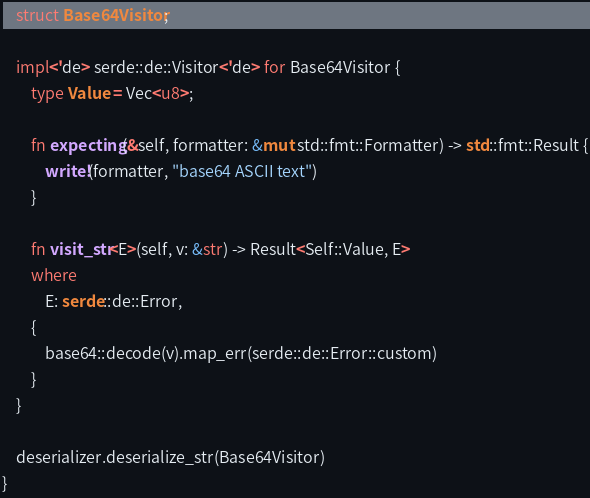Convert code to text. <code><loc_0><loc_0><loc_500><loc_500><_Rust_>    struct Base64Visitor;

    impl<'de> serde::de::Visitor<'de> for Base64Visitor {
        type Value = Vec<u8>;

        fn expecting(&self, formatter: &mut std::fmt::Formatter) -> std::fmt::Result {
            write!(formatter, "base64 ASCII text")
        }

        fn visit_str<E>(self, v: &str) -> Result<Self::Value, E>
        where
            E: serde::de::Error,
        {
            base64::decode(v).map_err(serde::de::Error::custom)
        }
    }

    deserializer.deserialize_str(Base64Visitor)
}
</code> 